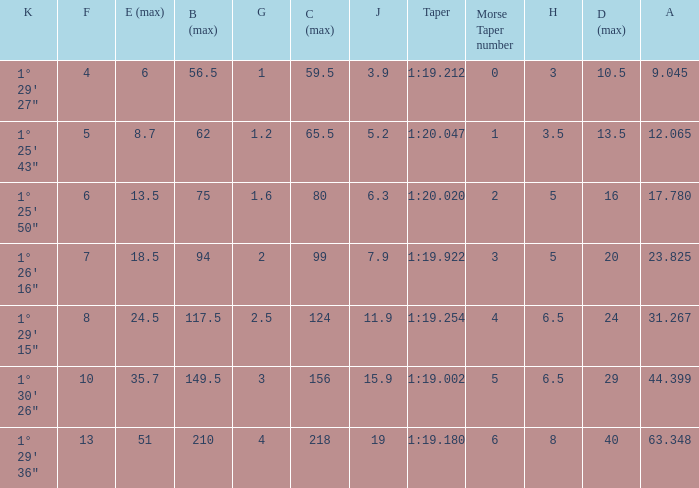Can you parse all the data within this table? {'header': ['K', 'F', 'E (max)', 'B (max)', 'G', 'C (max)', 'J', 'Taper', 'Morse Taper number', 'H', 'D (max)', 'A'], 'rows': [['1° 29\' 27"', '4', '6', '56.5', '1', '59.5', '3.9', '1:19.212', '0', '3', '10.5', '9.045'], ['1° 25\' 43"', '5', '8.7', '62', '1.2', '65.5', '5.2', '1:20.047', '1', '3.5', '13.5', '12.065'], ['1° 25\' 50"', '6', '13.5', '75', '1.6', '80', '6.3', '1:20.020', '2', '5', '16', '17.780'], ['1° 26\' 16"', '7', '18.5', '94', '2', '99', '7.9', '1:19.922', '3', '5', '20', '23.825'], ['1° 29\' 15"', '8', '24.5', '117.5', '2.5', '124', '11.9', '1:19.254', '4', '6.5', '24', '31.267'], ['1° 30\' 26"', '10', '35.7', '149.5', '3', '156', '15.9', '1:19.002', '5', '6.5', '29', '44.399'], ['1° 29\' 36"', '13', '51', '210', '4', '218', '19', '1:19.180', '6', '8', '40', '63.348']]} Name the h when c max is 99 5.0. 